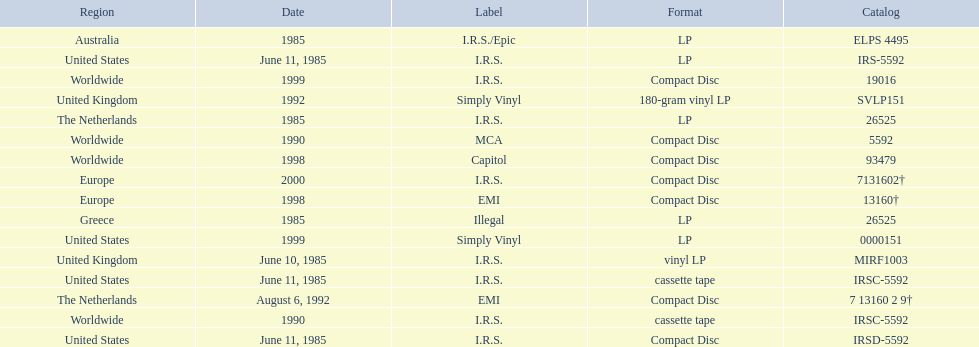Which dates were their releases by fables of the reconstruction? June 10, 1985, June 11, 1985, June 11, 1985, June 11, 1985, 1985, 1985, 1985, 1990, 1990, August 6, 1992, 1992, 1998, 1998, 1999, 1999, 2000. Which of these are in 1985? June 10, 1985, June 11, 1985, June 11, 1985, June 11, 1985, 1985, 1985, 1985. What regions were there releases on these dates? United Kingdom, United States, United States, United States, Greece, Australia, The Netherlands. Which of these are not greece? United Kingdom, United States, United States, United States, Australia, The Netherlands. Which of these regions have two labels listed? Australia. 